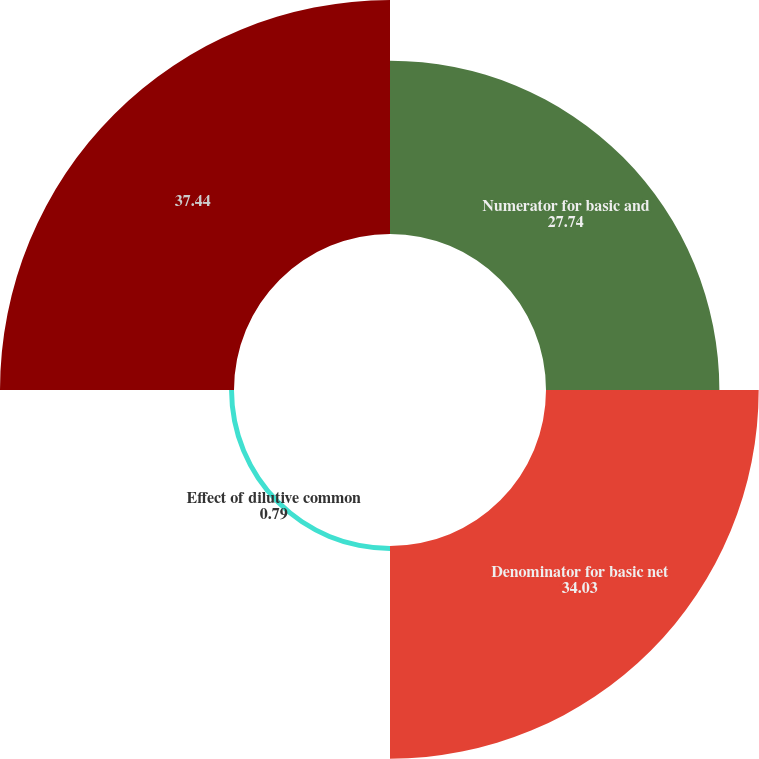Convert chart. <chart><loc_0><loc_0><loc_500><loc_500><pie_chart><fcel>Numerator for basic and<fcel>Denominator for basic net<fcel>Effect of dilutive common<fcel>Unnamed: 3<nl><fcel>27.74%<fcel>34.03%<fcel>0.79%<fcel>37.44%<nl></chart> 